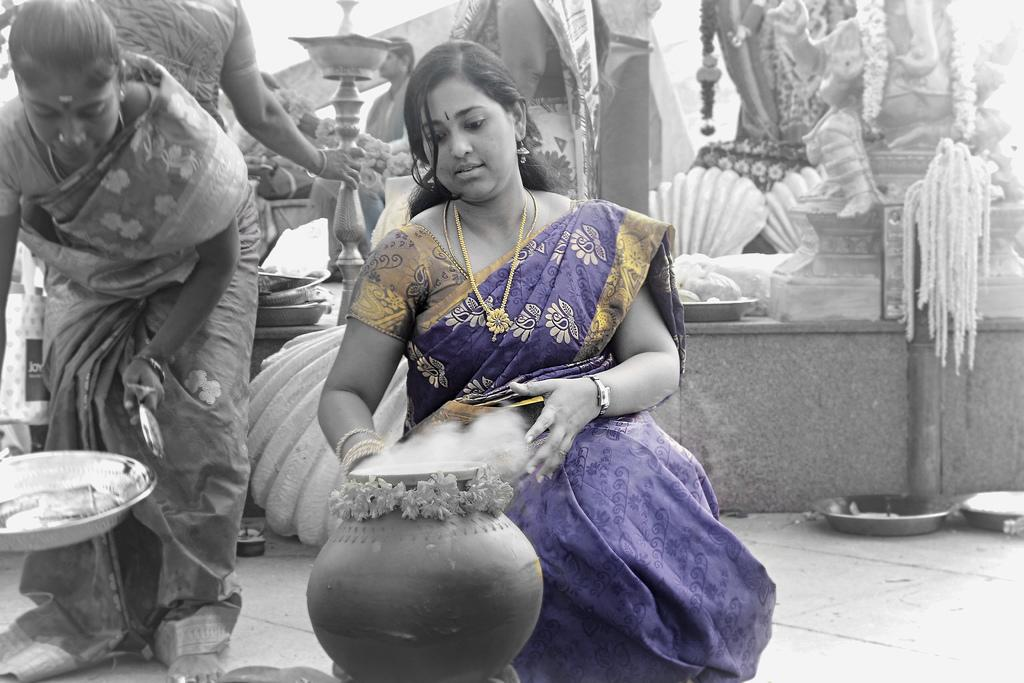How many women are in the image? There are two women in the image. Where is one of the women located? One of the women is on the right side. What is near the woman on the right? There is a pot near the woman on the right. Can you describe the background of the image? There are people and other objects or elements visible in the background. What type of game is being played by the women in the image? There is no game being played in the image; it only shows two women and a pot. Can you tell me how many buttons are on the woman's shirt in the image? There is no shirt visible in the image, and therefore no buttons can be counted. 